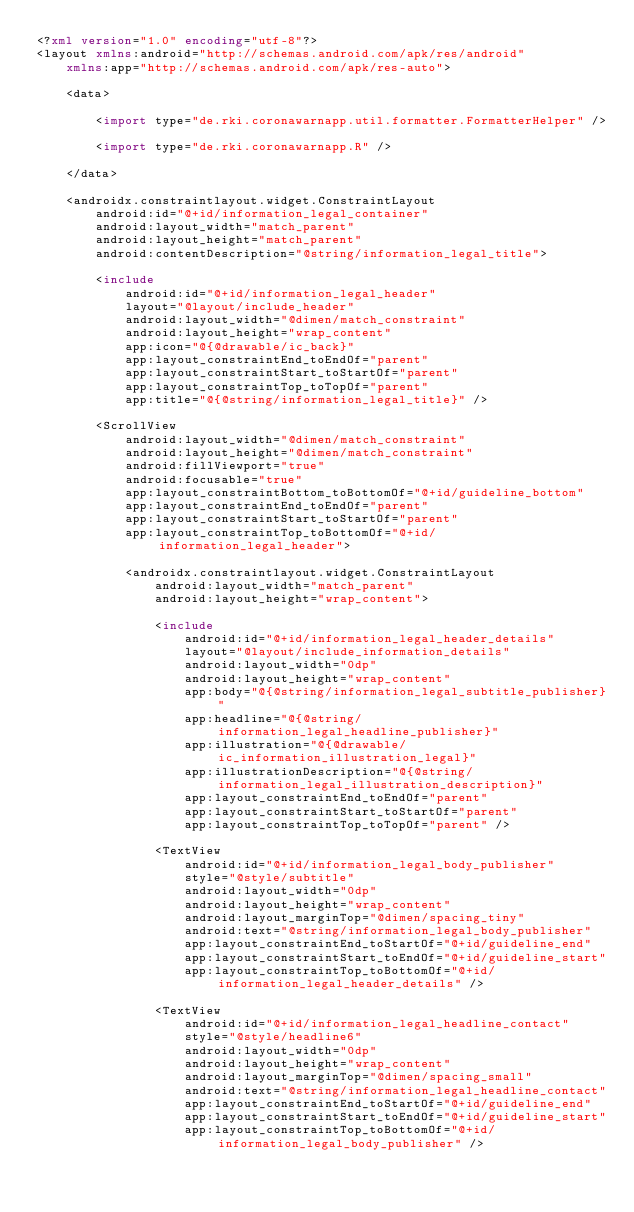<code> <loc_0><loc_0><loc_500><loc_500><_XML_><?xml version="1.0" encoding="utf-8"?>
<layout xmlns:android="http://schemas.android.com/apk/res/android"
    xmlns:app="http://schemas.android.com/apk/res-auto">

    <data>

        <import type="de.rki.coronawarnapp.util.formatter.FormatterHelper" />

        <import type="de.rki.coronawarnapp.R" />

    </data>

    <androidx.constraintlayout.widget.ConstraintLayout
        android:id="@+id/information_legal_container"
        android:layout_width="match_parent"
        android:layout_height="match_parent"
        android:contentDescription="@string/information_legal_title">

        <include
            android:id="@+id/information_legal_header"
            layout="@layout/include_header"
            android:layout_width="@dimen/match_constraint"
            android:layout_height="wrap_content"
            app:icon="@{@drawable/ic_back}"
            app:layout_constraintEnd_toEndOf="parent"
            app:layout_constraintStart_toStartOf="parent"
            app:layout_constraintTop_toTopOf="parent"
            app:title="@{@string/information_legal_title}" />

        <ScrollView
            android:layout_width="@dimen/match_constraint"
            android:layout_height="@dimen/match_constraint"
            android:fillViewport="true"
            android:focusable="true"
            app:layout_constraintBottom_toBottomOf="@+id/guideline_bottom"
            app:layout_constraintEnd_toEndOf="parent"
            app:layout_constraintStart_toStartOf="parent"
            app:layout_constraintTop_toBottomOf="@+id/information_legal_header">

            <androidx.constraintlayout.widget.ConstraintLayout
                android:layout_width="match_parent"
                android:layout_height="wrap_content">

                <include
                    android:id="@+id/information_legal_header_details"
                    layout="@layout/include_information_details"
                    android:layout_width="0dp"
                    android:layout_height="wrap_content"
                    app:body="@{@string/information_legal_subtitle_publisher}"
                    app:headline="@{@string/information_legal_headline_publisher}"
                    app:illustration="@{@drawable/ic_information_illustration_legal}"
                    app:illustrationDescription="@{@string/information_legal_illustration_description}"
                    app:layout_constraintEnd_toEndOf="parent"
                    app:layout_constraintStart_toStartOf="parent"
                    app:layout_constraintTop_toTopOf="parent" />

                <TextView
                    android:id="@+id/information_legal_body_publisher"
                    style="@style/subtitle"
                    android:layout_width="0dp"
                    android:layout_height="wrap_content"
                    android:layout_marginTop="@dimen/spacing_tiny"
                    android:text="@string/information_legal_body_publisher"
                    app:layout_constraintEnd_toStartOf="@+id/guideline_end"
                    app:layout_constraintStart_toEndOf="@+id/guideline_start"
                    app:layout_constraintTop_toBottomOf="@+id/information_legal_header_details" />

                <TextView
                    android:id="@+id/information_legal_headline_contact"
                    style="@style/headline6"
                    android:layout_width="0dp"
                    android:layout_height="wrap_content"
                    android:layout_marginTop="@dimen/spacing_small"
                    android:text="@string/information_legal_headline_contact"
                    app:layout_constraintEnd_toStartOf="@+id/guideline_end"
                    app:layout_constraintStart_toEndOf="@+id/guideline_start"
                    app:layout_constraintTop_toBottomOf="@+id/information_legal_body_publisher" />
</code> 